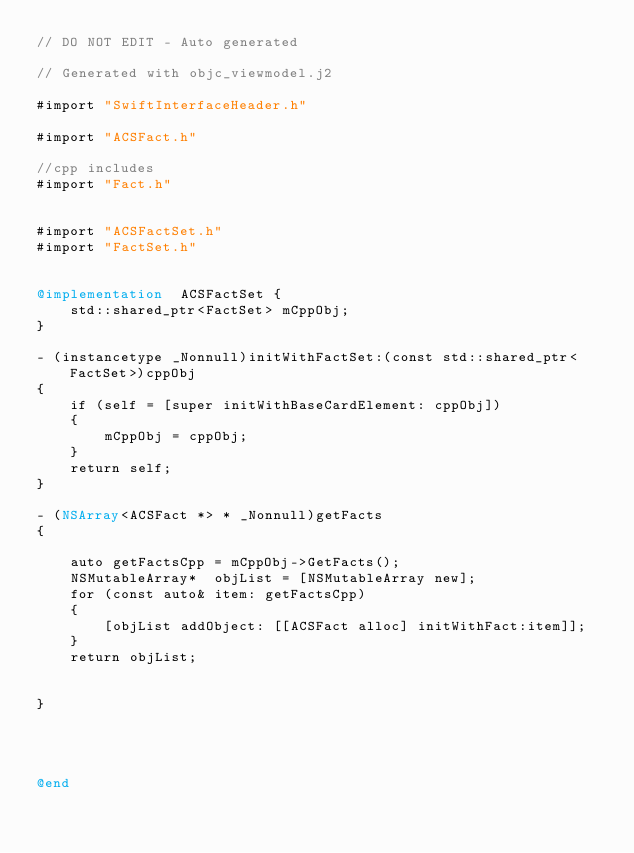<code> <loc_0><loc_0><loc_500><loc_500><_ObjectiveC_>// DO NOT EDIT - Auto generated

// Generated with objc_viewmodel.j2

#import "SwiftInterfaceHeader.h"

#import "ACSFact.h"

//cpp includes
#import "Fact.h"


#import "ACSFactSet.h"
#import "FactSet.h"


@implementation  ACSFactSet {
    std::shared_ptr<FactSet> mCppObj;
}

- (instancetype _Nonnull)initWithFactSet:(const std::shared_ptr<FactSet>)cppObj
{
    if (self = [super initWithBaseCardElement: cppObj])
    {
        mCppObj = cppObj;
    }
    return self;
}

- (NSArray<ACSFact *> * _Nonnull)getFacts
{
 
    auto getFactsCpp = mCppObj->GetFacts();
    NSMutableArray*  objList = [NSMutableArray new];
    for (const auto& item: getFactsCpp)
    {
        [objList addObject: [[ACSFact alloc] initWithFact:item]];
    }
    return objList;


}




@end
</code> 